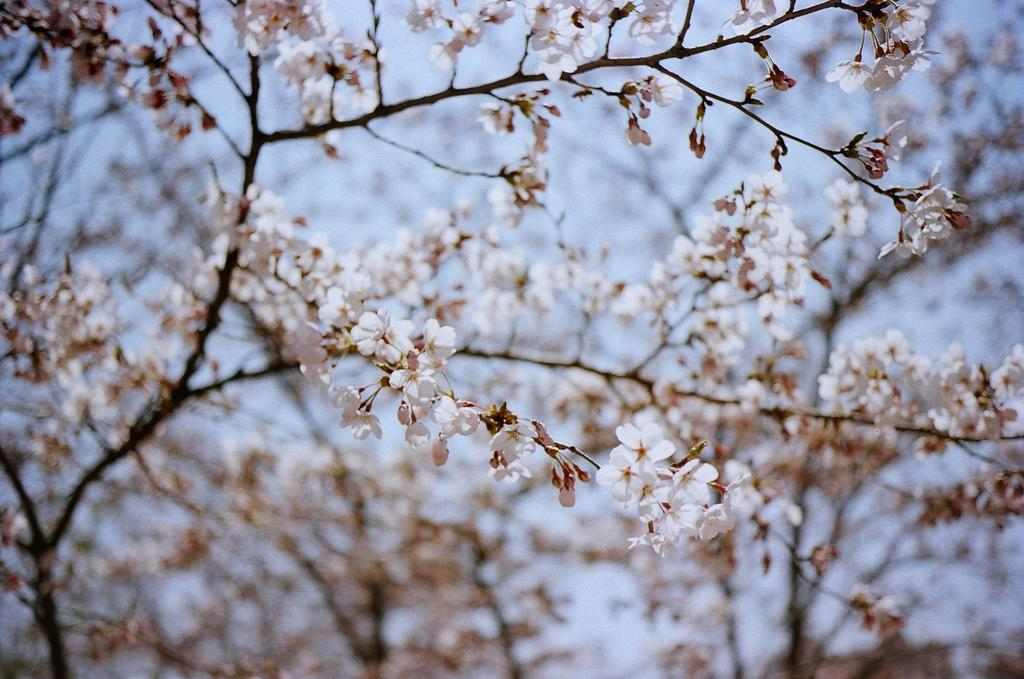What type of vegetation is present in the image? There are trees with flowers in the image. What can be seen in the background of the image? The sky is visible in the background of the image. What type of attention does the spark receive from the wall in the image? There is no spark or wall present in the image; it only features trees with flowers and the sky in the background. 